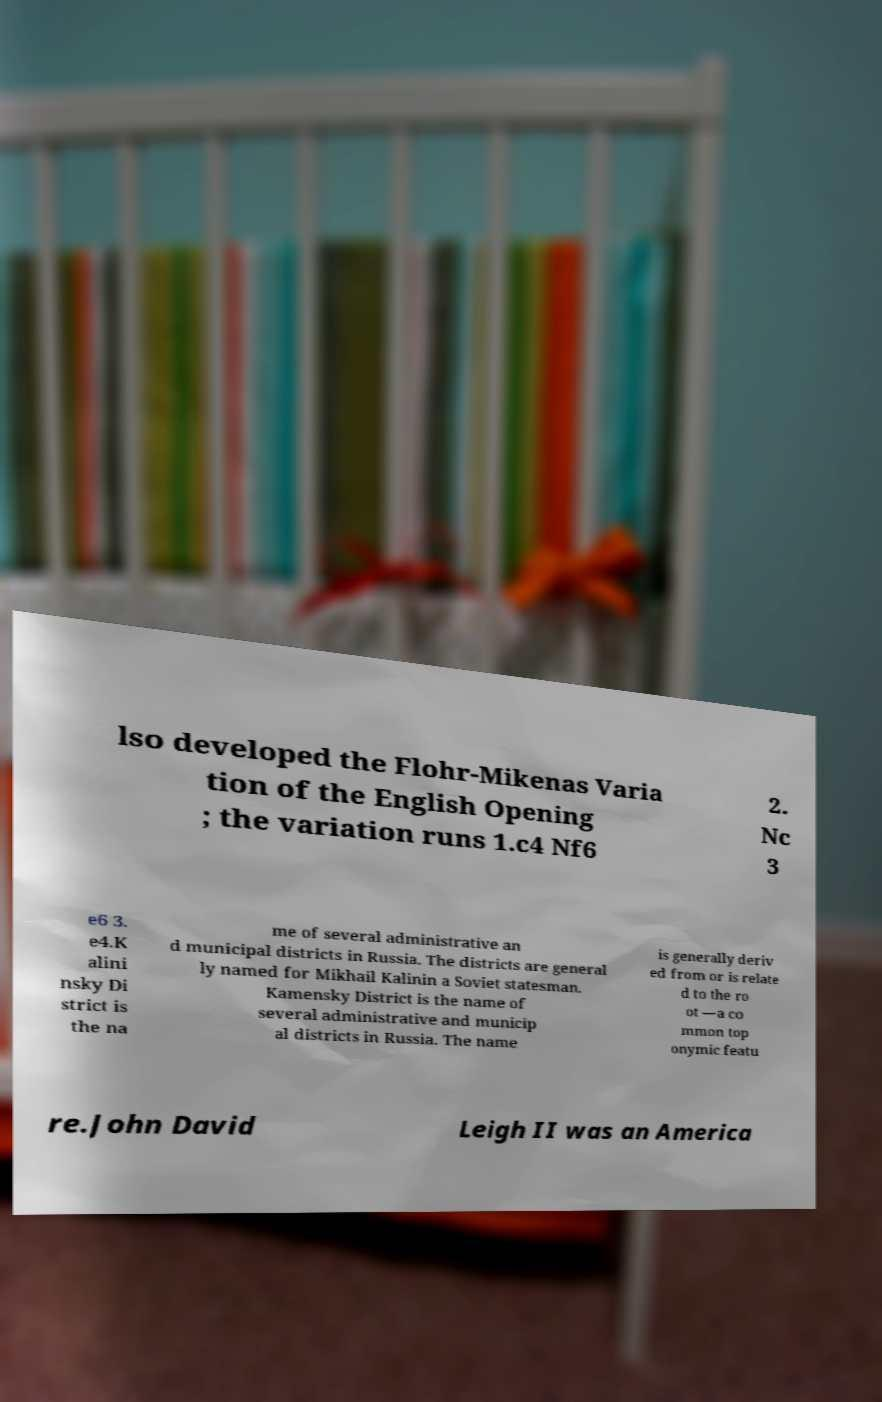There's text embedded in this image that I need extracted. Can you transcribe it verbatim? lso developed the Flohr-Mikenas Varia tion of the English Opening ; the variation runs 1.c4 Nf6 2. Nc 3 e6 3. e4.K alini nsky Di strict is the na me of several administrative an d municipal districts in Russia. The districts are general ly named for Mikhail Kalinin a Soviet statesman. Kamensky District is the name of several administrative and municip al districts in Russia. The name is generally deriv ed from or is relate d to the ro ot —a co mmon top onymic featu re.John David Leigh II was an America 